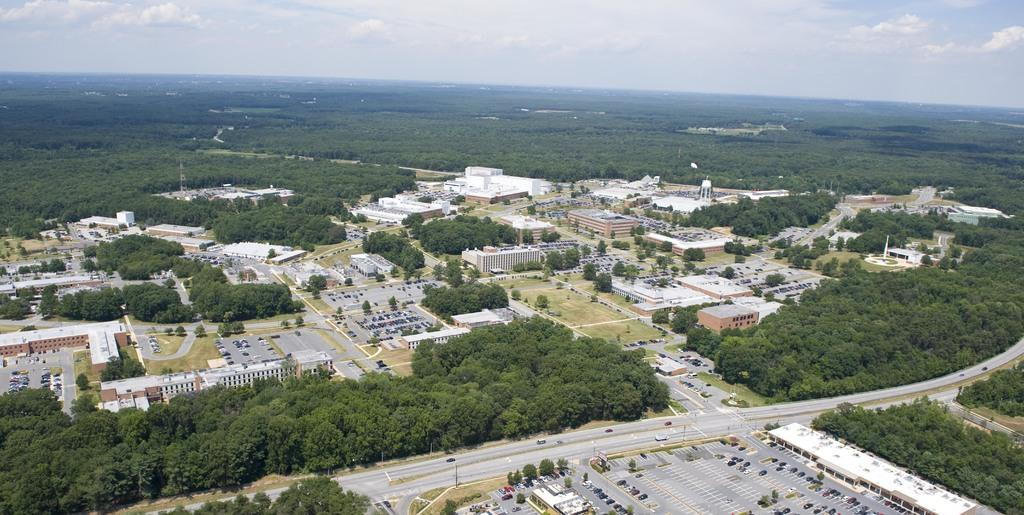What type of structures can be seen in the image? There are buildings and a tower in the image. What other objects can be seen in the image? There are trees, poles, and vehicles in the image. Where is the map located in the image? There is no map present in the image. What type of station can be seen in the image? There is no station present in the image. 